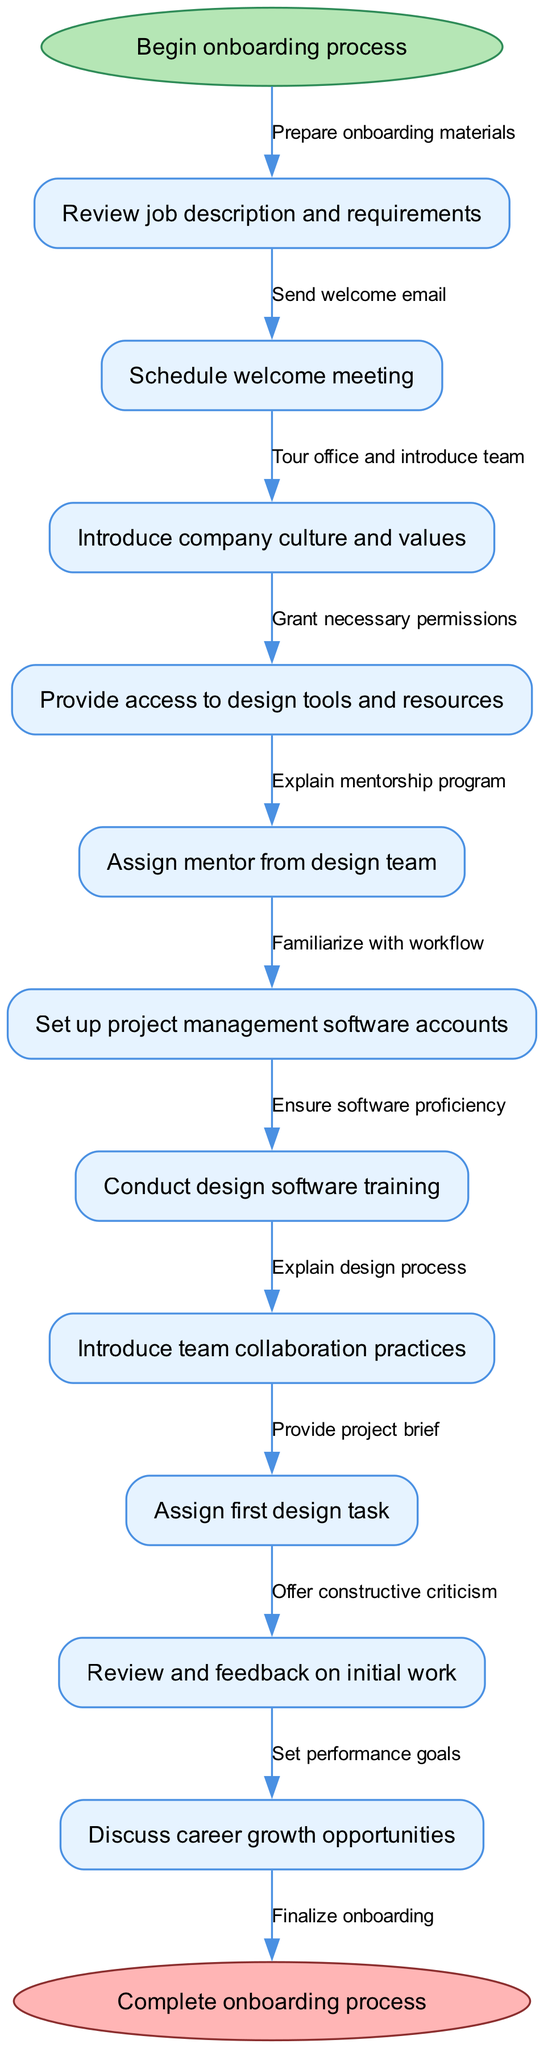What is the starting point of the onboarding process? The diagram indicates that the starting point is labeled as "Begin onboarding process". This is the first node that initiates the entire onboarding workflow.
Answer: Begin onboarding process How many nodes are there in total in the diagram? By counting the nodes listed in the data, including the start and end nodes, we find a total of 12 nodes (1 start, 10 process nodes, 1 end).
Answer: 12 What is the last task in the onboarding process? The last task to be completed before concluding the onboarding process is "Finalize onboarding". This is identified by looking for the connection to the end node from the last task node in the diagram.
Answer: Finalize onboarding Which node is directly connected to "Conduct design software training"? "Conduct design software training" is followed by the node "Introduce team collaboration practices", indicating they are directly connected in the flow of the onboarding process.
Answer: Introduce team collaboration practices What procedure immediately follows "Assign first design task"? The procedure that follows "Assign first design task" is "Review and feedback on initial work". This comes in the sequence of actions taken during the onboarding workflow.
Answer: Review and feedback on initial work What is the purpose of the node labeled "Assign mentor from design team"? The purpose of this node is to establish a mentorship relationship that helps the new UI/UX designer navigate their onboarding experience effectively. It aims to enhance support and guidance.
Answer: To establish mentorship How does the onboarding process begin structurally? The onboarding process begins structurally with a single entry point, directly leading to the next step, which emphasizes a sequential approach to onboarding. The initial step is "Review job description and requirements".
Answer: Review job description and requirements What is the overall goal of the onboarding workflow as depicted in the diagram? The overall goal is to successfully integrate a new UI/UX designer into the company, ensuring they are familiar with all necessary tools, practices, and the company culture by the end of the process. This is clearly indicated through the flow leading to the completion.
Answer: Complete onboarding process What is the role of the node "Explain mentorship program"? The role of this node is to provide information about the mentorship structure aimed at assisting the new designer and ensuring they understand how to leverage the support available to them during their onboarding.
Answer: To provide information about mentorship What action occurs after granting necessary permissions? After granting necessary permissions, the next action is to "Explain design process", which continues the workflow by informing the new hire about how design work is conducted within the company.
Answer: Explain design process 